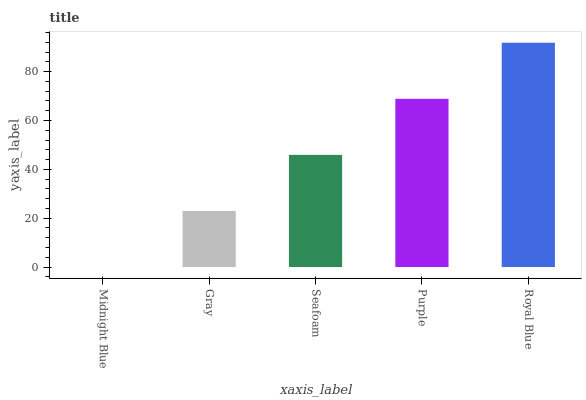Is Gray the minimum?
Answer yes or no. No. Is Gray the maximum?
Answer yes or no. No. Is Gray greater than Midnight Blue?
Answer yes or no. Yes. Is Midnight Blue less than Gray?
Answer yes or no. Yes. Is Midnight Blue greater than Gray?
Answer yes or no. No. Is Gray less than Midnight Blue?
Answer yes or no. No. Is Seafoam the high median?
Answer yes or no. Yes. Is Seafoam the low median?
Answer yes or no. Yes. Is Royal Blue the high median?
Answer yes or no. No. Is Gray the low median?
Answer yes or no. No. 